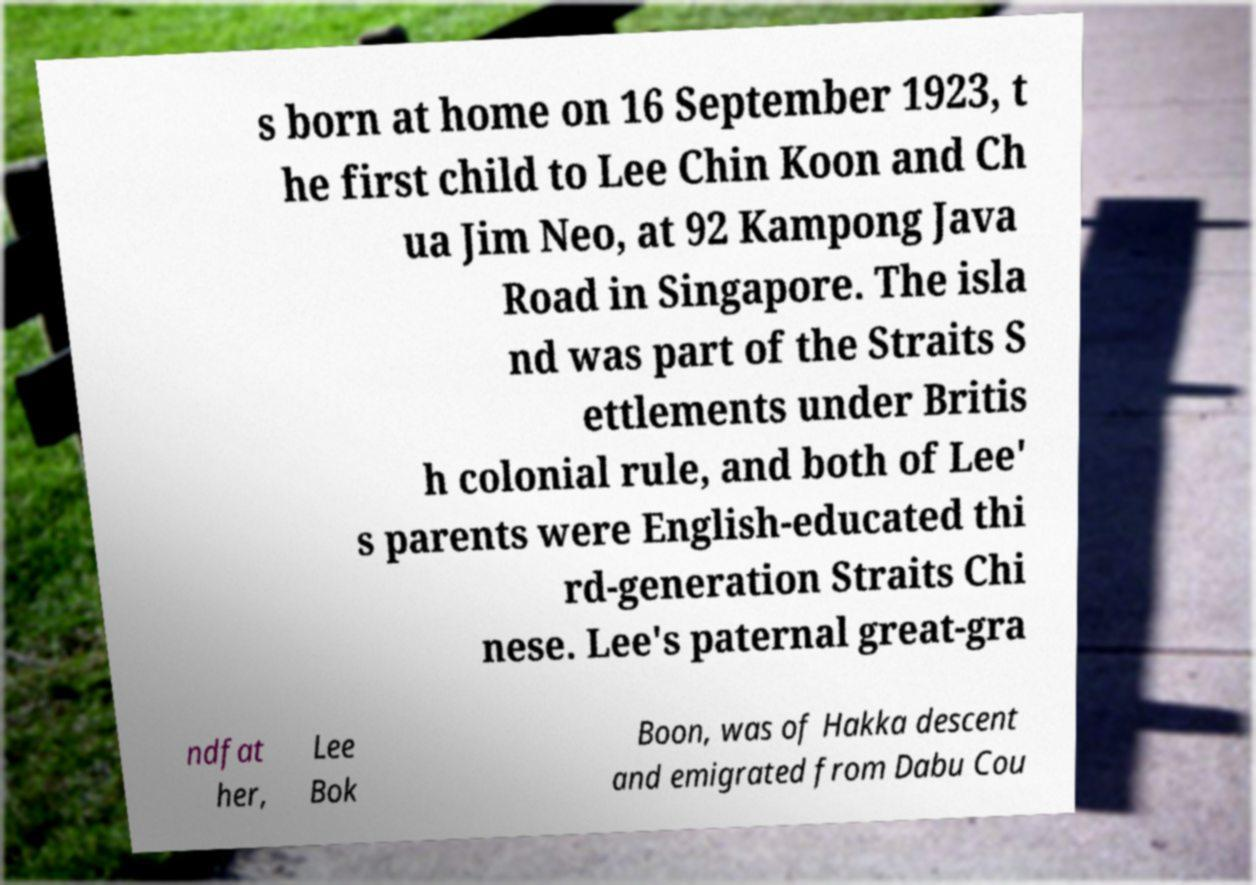Can you read and provide the text displayed in the image?This photo seems to have some interesting text. Can you extract and type it out for me? s born at home on 16 September 1923, t he first child to Lee Chin Koon and Ch ua Jim Neo, at 92 Kampong Java Road in Singapore. The isla nd was part of the Straits S ettlements under Britis h colonial rule, and both of Lee' s parents were English-educated thi rd-generation Straits Chi nese. Lee's paternal great-gra ndfat her, Lee Bok Boon, was of Hakka descent and emigrated from Dabu Cou 